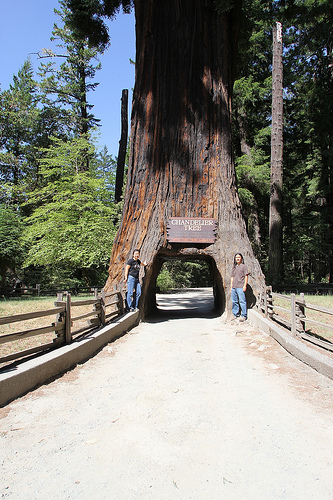<image>
Can you confirm if the tree is on the tree? No. The tree is not positioned on the tree. They may be near each other, but the tree is not supported by or resting on top of the tree. Where is the hole in relation to the tree? Is it in the tree? Yes. The hole is contained within or inside the tree, showing a containment relationship. Where is the road in relation to the tree? Is it in front of the tree? No. The road is not in front of the tree. The spatial positioning shows a different relationship between these objects. 